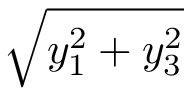Convert formula to latex. <formula><loc_0><loc_0><loc_500><loc_500>\sqrt { y _ { 1 } ^ { 2 } + y _ { 3 } ^ { 2 } }</formula> 